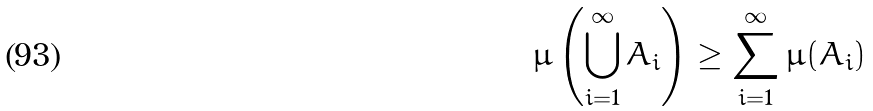Convert formula to latex. <formula><loc_0><loc_0><loc_500><loc_500>\mu \left ( \bigcup _ { i = 1 } ^ { \infty } A _ { i } \right ) \geq \sum _ { i = 1 } ^ { \infty } \mu ( A _ { i } )</formula> 